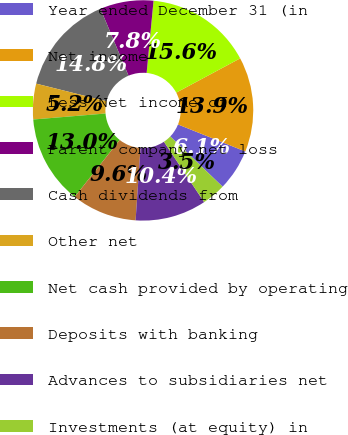Convert chart to OTSL. <chart><loc_0><loc_0><loc_500><loc_500><pie_chart><fcel>Year ended December 31 (in<fcel>Net income<fcel>Less Net income of<fcel>Parent company net loss<fcel>Cash dividends from<fcel>Other net<fcel>Net cash provided by operating<fcel>Deposits with banking<fcel>Advances to subsidiaries net<fcel>Investments (at equity) in<nl><fcel>6.09%<fcel>13.91%<fcel>15.65%<fcel>7.83%<fcel>14.78%<fcel>5.22%<fcel>13.04%<fcel>9.57%<fcel>10.43%<fcel>3.48%<nl></chart> 